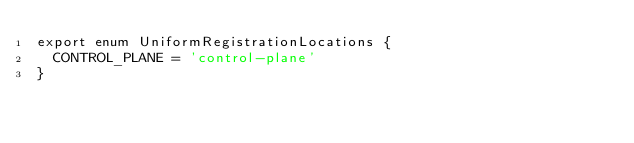<code> <loc_0><loc_0><loc_500><loc_500><_TypeScript_>export enum UniformRegistrationLocations {
  CONTROL_PLANE = 'control-plane'
}
</code> 